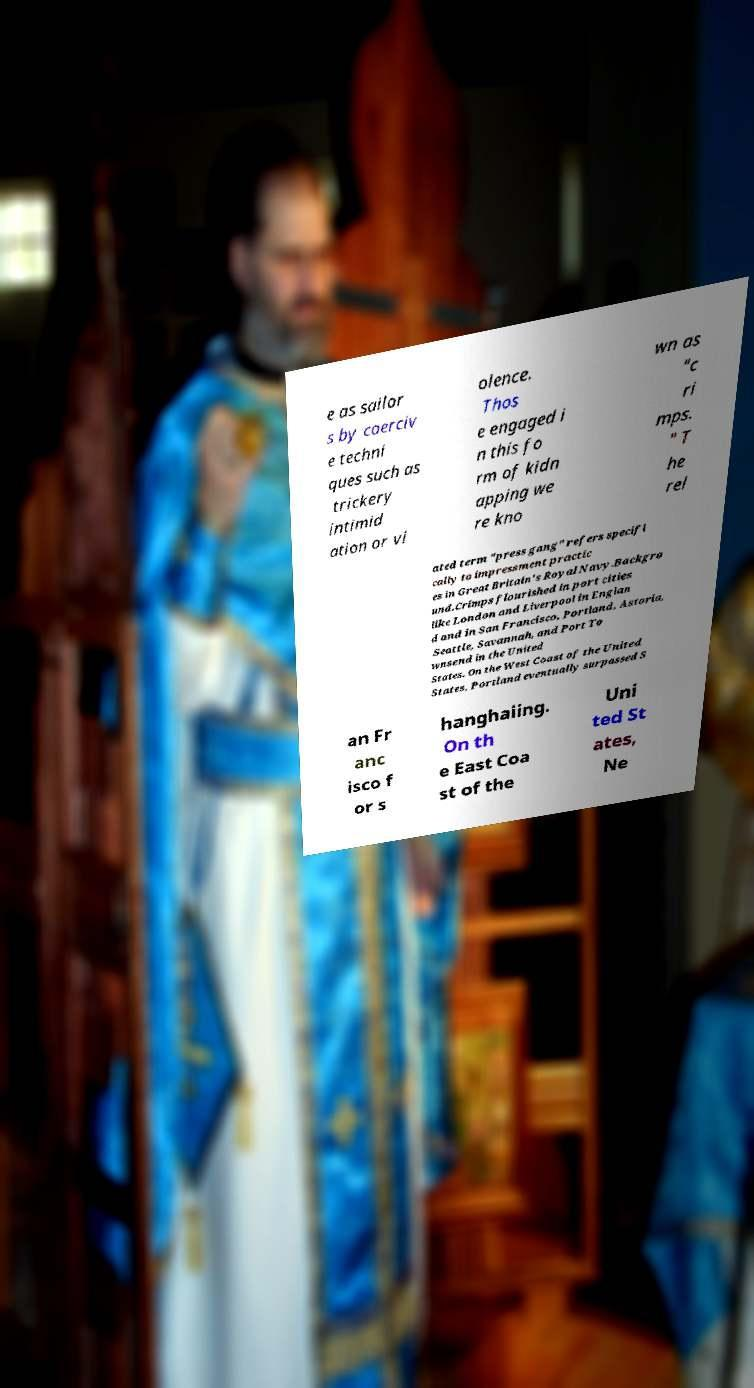Please identify and transcribe the text found in this image. e as sailor s by coerciv e techni ques such as trickery intimid ation or vi olence. Thos e engaged i n this fo rm of kidn apping we re kno wn as "c ri mps. " T he rel ated term "press gang" refers specifi cally to impressment practic es in Great Britain's Royal Navy.Backgro und.Crimps flourished in port cities like London and Liverpool in Englan d and in San Francisco, Portland, Astoria, Seattle, Savannah, and Port To wnsend in the United States. On the West Coast of the United States, Portland eventually surpassed S an Fr anc isco f or s hanghaiing. On th e East Coa st of the Uni ted St ates, Ne 